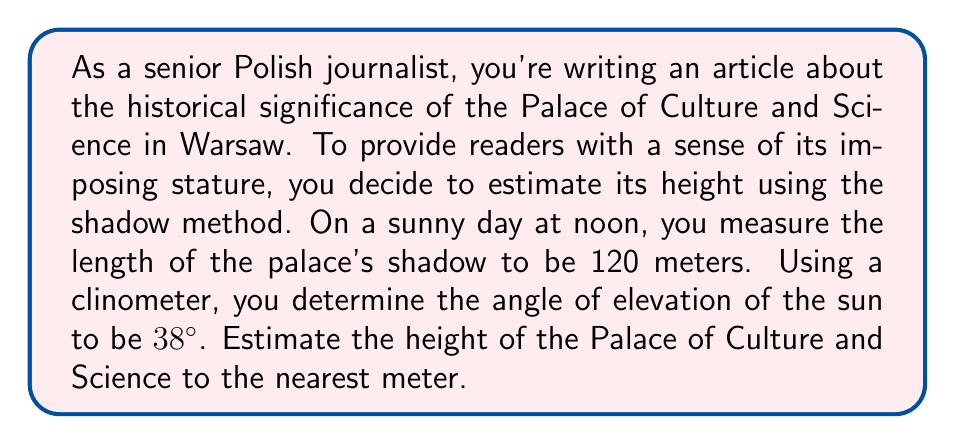Give your solution to this math problem. Let's approach this problem step-by-step using trigonometry:

1) First, let's visualize the scenario:

[asy]
import geometry;

size(200);
pair A = (0,0), B = (120,0), C = (0,90);
draw(A--B--C--A);
draw(rightangle(A,B,C,20));

label("Ground", (60,-5));
label("Shadow (120 m)", (60,-15));
label("Building Height", (-15,45));
label("38°", (10,10), NE);

draw(arc(A,15,0,38), Arrow);
[/asy]

2) In this right-angled triangle:
   - The shadow length forms the adjacent side (120 m)
   - The building height forms the opposite side (what we're solving for)
   - The angle of elevation of the sun is 38°

3) We can use the tangent trigonometric function to find the height:

   $$\tan(\theta) = \frac{\text{opposite}}{\text{adjacent}}$$

4) Substituting our known values:

   $$\tan(38°) = \frac{\text{height}}{120}$$

5) Rearranging to solve for height:

   $$\text{height} = 120 \cdot \tan(38°)$$

6) Now we can calculate:
   
   $$\text{height} = 120 \cdot \tan(38°) \approx 120 \cdot 0.7813 \approx 93.756 \text{ meters}$$

7) Rounding to the nearest meter as requested:

   $$\text{height} \approx 94 \text{ meters}$$
Answer: The estimated height of the Palace of Culture and Science is approximately 94 meters. 